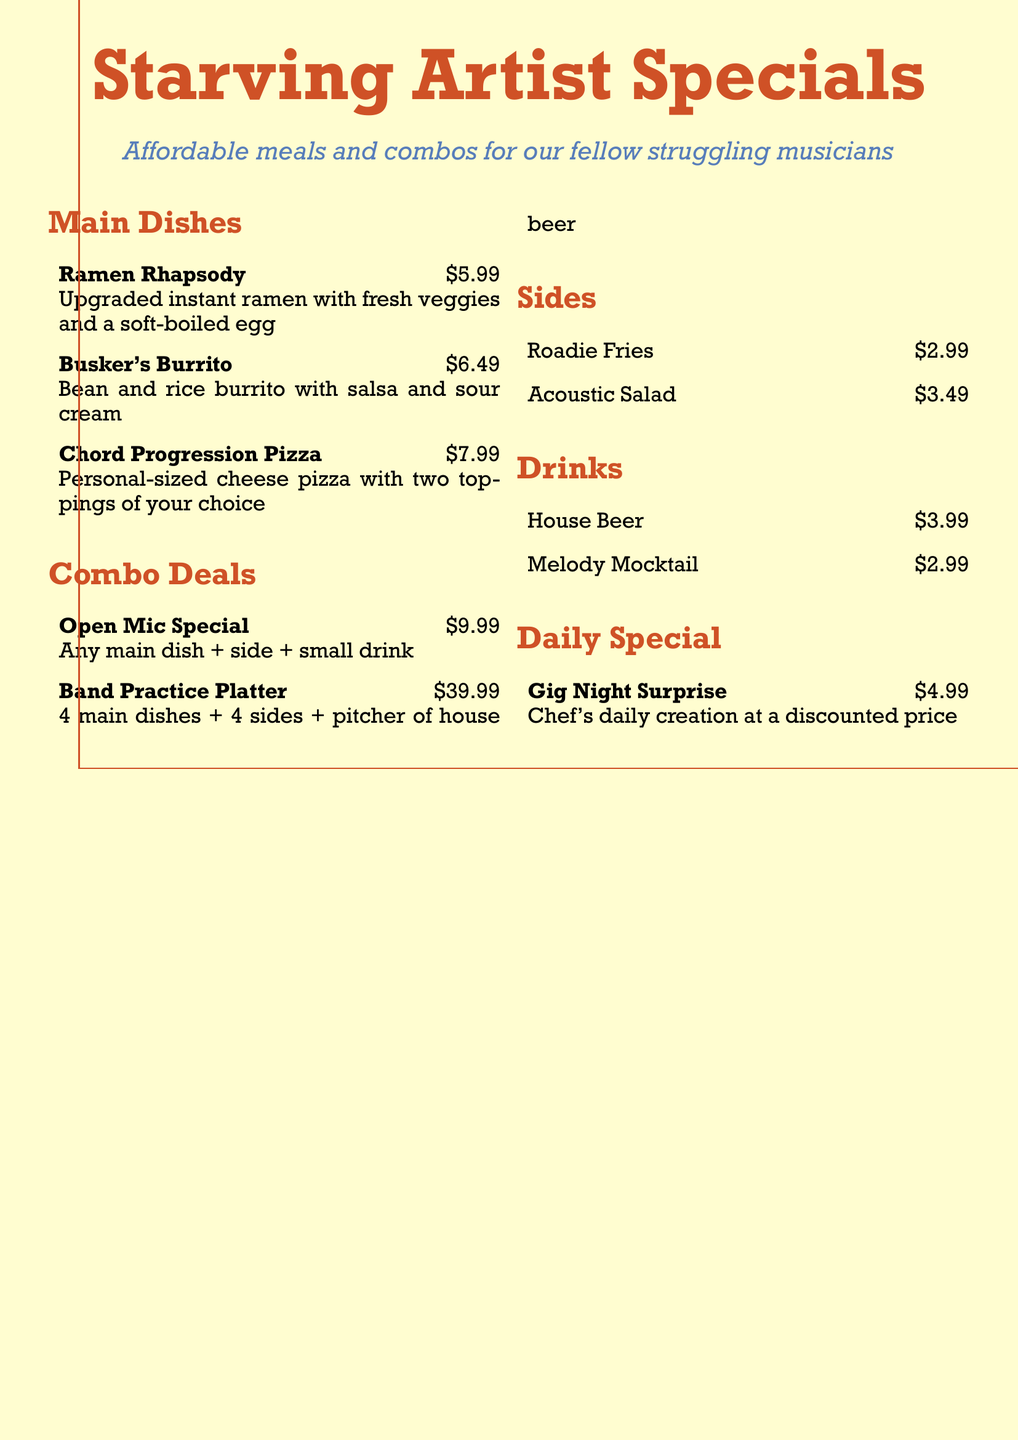What is the price of Ramen Rhapsody? The price of Ramen Rhapsody is stated in the menu.
Answer: $5.99 What are the two options available for the Band Practice Platter? The Band Practice Platter includes 4 main dishes and 4 sides.
Answer: 4 main dishes + 4 sides What is the price of the Melody Mocktail? The price of the Melody Mocktail is listed under the drinks section.
Answer: $2.99 Which dish is available for $4.99? The daily special is specifically highlighted with its price, which is $4.99.
Answer: Gig Night Surprise How many toppings can you choose for the Chord Progression Pizza? The Chord Progression Pizza allows the selection of two toppings, as mentioned.
Answer: Two toppings What is included in the Open Mic Special? The details of the Open Mic Special include one main dish, a side, and a small drink.
Answer: Any main dish + side + small drink What section of the menu features affordable meals? The section title explicitly mentions affordable meals tailored for musicians.
Answer: Starving Artist Specials What is the price of Acoustic Salad? The specific price for Acoustic Salad is provided in the sides section.
Answer: $3.49 